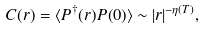Convert formula to latex. <formula><loc_0><loc_0><loc_500><loc_500>C ( { r } ) = \langle P ^ { \dagger } ( { r } ) P ( 0 ) \rangle \sim | { r } | ^ { - \eta ( T ) } ,</formula> 